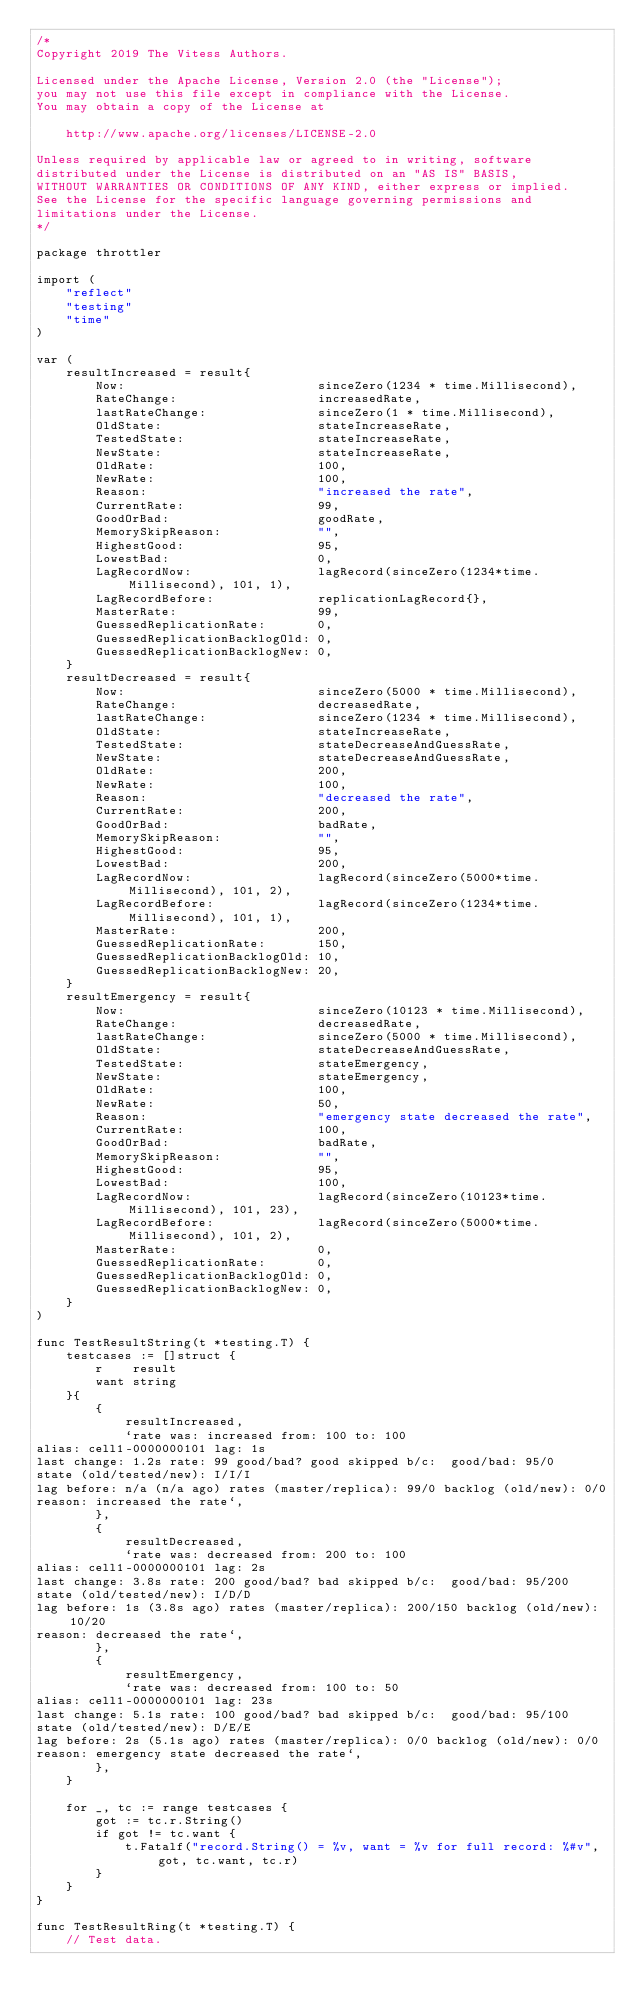<code> <loc_0><loc_0><loc_500><loc_500><_Go_>/*
Copyright 2019 The Vitess Authors.

Licensed under the Apache License, Version 2.0 (the "License");
you may not use this file except in compliance with the License.
You may obtain a copy of the License at

    http://www.apache.org/licenses/LICENSE-2.0

Unless required by applicable law or agreed to in writing, software
distributed under the License is distributed on an "AS IS" BASIS,
WITHOUT WARRANTIES OR CONDITIONS OF ANY KIND, either express or implied.
See the License for the specific language governing permissions and
limitations under the License.
*/

package throttler

import (
	"reflect"
	"testing"
	"time"
)

var (
	resultIncreased = result{
		Now:                          sinceZero(1234 * time.Millisecond),
		RateChange:                   increasedRate,
		lastRateChange:               sinceZero(1 * time.Millisecond),
		OldState:                     stateIncreaseRate,
		TestedState:                  stateIncreaseRate,
		NewState:                     stateIncreaseRate,
		OldRate:                      100,
		NewRate:                      100,
		Reason:                       "increased the rate",
		CurrentRate:                  99,
		GoodOrBad:                    goodRate,
		MemorySkipReason:             "",
		HighestGood:                  95,
		LowestBad:                    0,
		LagRecordNow:                 lagRecord(sinceZero(1234*time.Millisecond), 101, 1),
		LagRecordBefore:              replicationLagRecord{},
		MasterRate:                   99,
		GuessedReplicationRate:       0,
		GuessedReplicationBacklogOld: 0,
		GuessedReplicationBacklogNew: 0,
	}
	resultDecreased = result{
		Now:                          sinceZero(5000 * time.Millisecond),
		RateChange:                   decreasedRate,
		lastRateChange:               sinceZero(1234 * time.Millisecond),
		OldState:                     stateIncreaseRate,
		TestedState:                  stateDecreaseAndGuessRate,
		NewState:                     stateDecreaseAndGuessRate,
		OldRate:                      200,
		NewRate:                      100,
		Reason:                       "decreased the rate",
		CurrentRate:                  200,
		GoodOrBad:                    badRate,
		MemorySkipReason:             "",
		HighestGood:                  95,
		LowestBad:                    200,
		LagRecordNow:                 lagRecord(sinceZero(5000*time.Millisecond), 101, 2),
		LagRecordBefore:              lagRecord(sinceZero(1234*time.Millisecond), 101, 1),
		MasterRate:                   200,
		GuessedReplicationRate:       150,
		GuessedReplicationBacklogOld: 10,
		GuessedReplicationBacklogNew: 20,
	}
	resultEmergency = result{
		Now:                          sinceZero(10123 * time.Millisecond),
		RateChange:                   decreasedRate,
		lastRateChange:               sinceZero(5000 * time.Millisecond),
		OldState:                     stateDecreaseAndGuessRate,
		TestedState:                  stateEmergency,
		NewState:                     stateEmergency,
		OldRate:                      100,
		NewRate:                      50,
		Reason:                       "emergency state decreased the rate",
		CurrentRate:                  100,
		GoodOrBad:                    badRate,
		MemorySkipReason:             "",
		HighestGood:                  95,
		LowestBad:                    100,
		LagRecordNow:                 lagRecord(sinceZero(10123*time.Millisecond), 101, 23),
		LagRecordBefore:              lagRecord(sinceZero(5000*time.Millisecond), 101, 2),
		MasterRate:                   0,
		GuessedReplicationRate:       0,
		GuessedReplicationBacklogOld: 0,
		GuessedReplicationBacklogNew: 0,
	}
)

func TestResultString(t *testing.T) {
	testcases := []struct {
		r    result
		want string
	}{
		{
			resultIncreased,
			`rate was: increased from: 100 to: 100
alias: cell1-0000000101 lag: 1s
last change: 1.2s rate: 99 good/bad? good skipped b/c:  good/bad: 95/0
state (old/tested/new): I/I/I 
lag before: n/a (n/a ago) rates (master/replica): 99/0 backlog (old/new): 0/0
reason: increased the rate`,
		},
		{
			resultDecreased,
			`rate was: decreased from: 200 to: 100
alias: cell1-0000000101 lag: 2s
last change: 3.8s rate: 200 good/bad? bad skipped b/c:  good/bad: 95/200
state (old/tested/new): I/D/D 
lag before: 1s (3.8s ago) rates (master/replica): 200/150 backlog (old/new): 10/20
reason: decreased the rate`,
		},
		{
			resultEmergency,
			`rate was: decreased from: 100 to: 50
alias: cell1-0000000101 lag: 23s
last change: 5.1s rate: 100 good/bad? bad skipped b/c:  good/bad: 95/100
state (old/tested/new): D/E/E 
lag before: 2s (5.1s ago) rates (master/replica): 0/0 backlog (old/new): 0/0
reason: emergency state decreased the rate`,
		},
	}

	for _, tc := range testcases {
		got := tc.r.String()
		if got != tc.want {
			t.Fatalf("record.String() = %v, want = %v for full record: %#v", got, tc.want, tc.r)
		}
	}
}

func TestResultRing(t *testing.T) {
	// Test data.</code> 